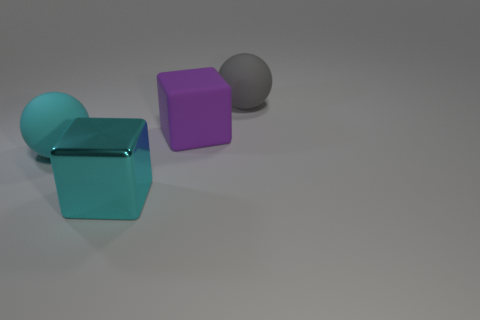Do the matte sphere in front of the gray sphere and the sphere to the right of the purple rubber object have the same size?
Provide a short and direct response. Yes. Is there anything else that is the same material as the gray thing?
Offer a terse response. Yes. What number of big things are either cyan metallic cubes or rubber cubes?
Your answer should be compact. 2. How many objects are either large rubber balls that are to the left of the big gray object or large brown matte cylinders?
Your answer should be very brief. 1. Is the metal thing the same color as the rubber block?
Offer a terse response. No. How many other things are the same shape as the big gray rubber object?
Ensure brevity in your answer.  1. How many yellow things are either rubber blocks or balls?
Your answer should be very brief. 0. There is a large block that is the same material as the large gray sphere; what is its color?
Offer a terse response. Purple. Does the ball that is in front of the purple matte thing have the same material as the big sphere that is on the right side of the large cyan metal object?
Provide a short and direct response. Yes. What is the size of the rubber sphere that is the same color as the big metal thing?
Provide a succinct answer. Large. 